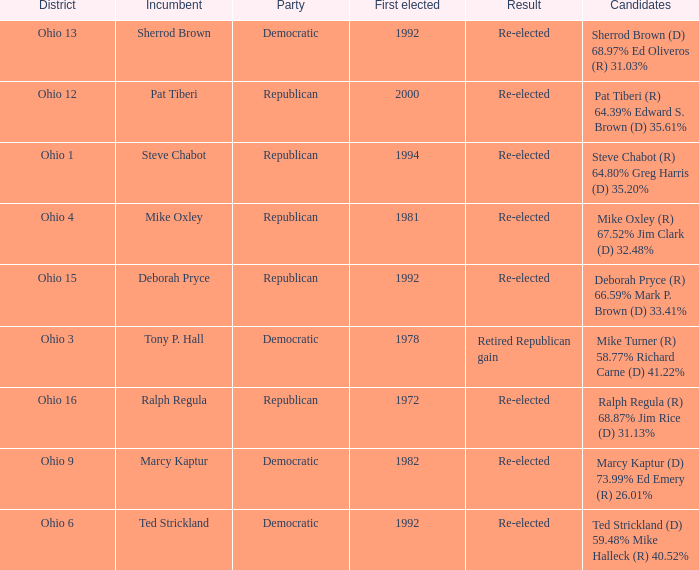In what district was the incumbent Steve Chabot?  Ohio 1. 